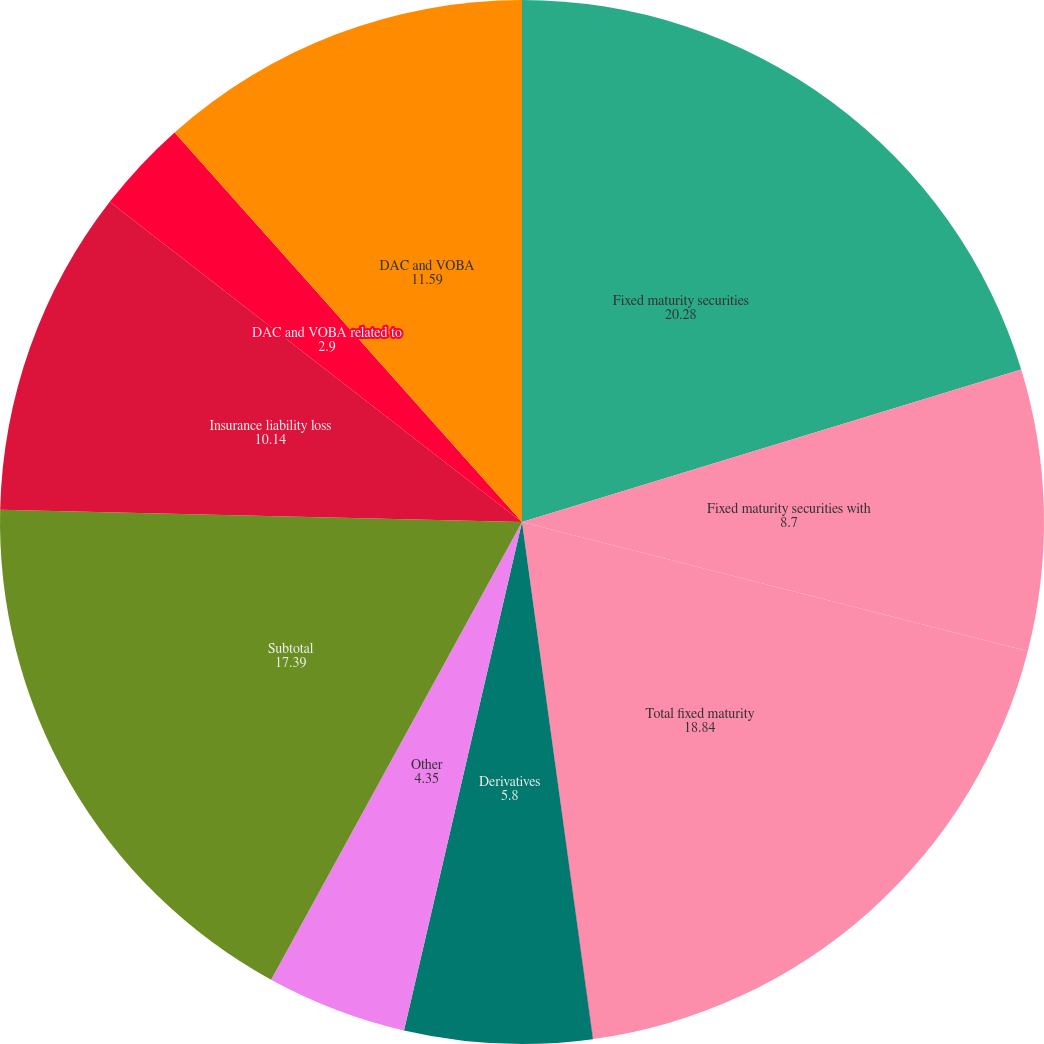Convert chart. <chart><loc_0><loc_0><loc_500><loc_500><pie_chart><fcel>Fixed maturity securities<fcel>Fixed maturity securities with<fcel>Total fixed maturity<fcel>Equity securities<fcel>Derivatives<fcel>Other<fcel>Subtotal<fcel>Insurance liability loss<fcel>DAC and VOBA related to<fcel>DAC and VOBA<nl><fcel>20.28%<fcel>8.7%<fcel>18.84%<fcel>0.01%<fcel>5.8%<fcel>4.35%<fcel>17.39%<fcel>10.14%<fcel>2.9%<fcel>11.59%<nl></chart> 